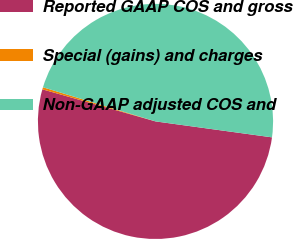Convert chart to OTSL. <chart><loc_0><loc_0><loc_500><loc_500><pie_chart><fcel>Reported GAAP COS and gross<fcel>Special (gains) and charges<fcel>Non-GAAP adjusted COS and<nl><fcel>52.23%<fcel>0.29%<fcel>47.48%<nl></chart> 